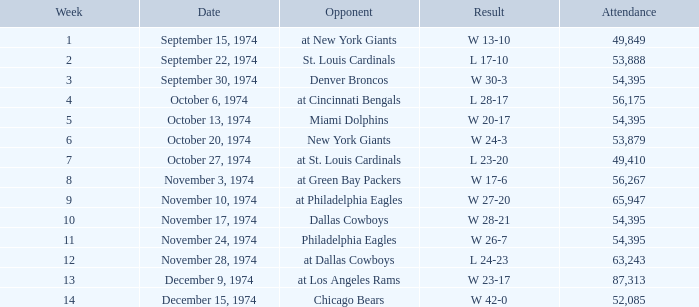What is the week of the game played on November 28, 1974? 12.0. 